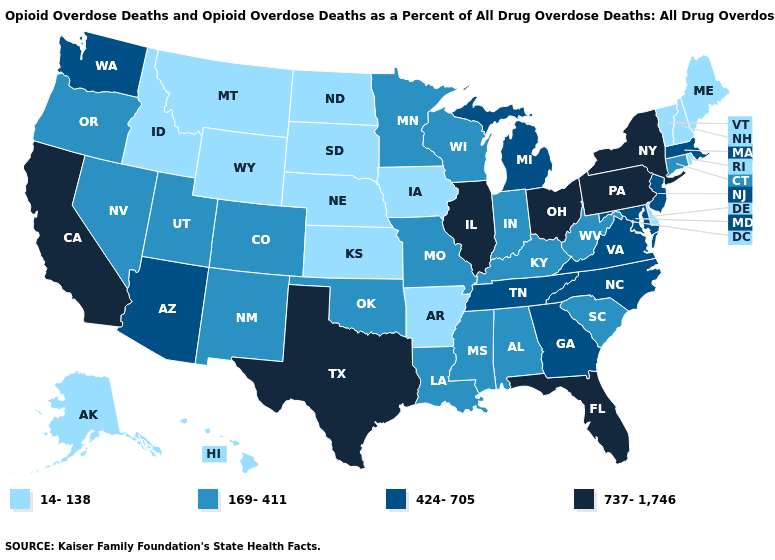Name the states that have a value in the range 14-138?
Write a very short answer. Alaska, Arkansas, Delaware, Hawaii, Idaho, Iowa, Kansas, Maine, Montana, Nebraska, New Hampshire, North Dakota, Rhode Island, South Dakota, Vermont, Wyoming. Name the states that have a value in the range 169-411?
Short answer required. Alabama, Colorado, Connecticut, Indiana, Kentucky, Louisiana, Minnesota, Mississippi, Missouri, Nevada, New Mexico, Oklahoma, Oregon, South Carolina, Utah, West Virginia, Wisconsin. What is the highest value in the USA?
Give a very brief answer. 737-1,746. What is the highest value in the USA?
Quick response, please. 737-1,746. What is the value of Wyoming?
Be succinct. 14-138. Does Wyoming have the same value as Arkansas?
Give a very brief answer. Yes. What is the lowest value in the West?
Answer briefly. 14-138. What is the lowest value in the USA?
Be succinct. 14-138. Name the states that have a value in the range 14-138?
Write a very short answer. Alaska, Arkansas, Delaware, Hawaii, Idaho, Iowa, Kansas, Maine, Montana, Nebraska, New Hampshire, North Dakota, Rhode Island, South Dakota, Vermont, Wyoming. How many symbols are there in the legend?
Quick response, please. 4. Does Rhode Island have the lowest value in the Northeast?
Give a very brief answer. Yes. Name the states that have a value in the range 14-138?
Write a very short answer. Alaska, Arkansas, Delaware, Hawaii, Idaho, Iowa, Kansas, Maine, Montana, Nebraska, New Hampshire, North Dakota, Rhode Island, South Dakota, Vermont, Wyoming. Does West Virginia have the same value as New York?
Write a very short answer. No. Name the states that have a value in the range 14-138?
Be succinct. Alaska, Arkansas, Delaware, Hawaii, Idaho, Iowa, Kansas, Maine, Montana, Nebraska, New Hampshire, North Dakota, Rhode Island, South Dakota, Vermont, Wyoming. 